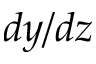<formula> <loc_0><loc_0><loc_500><loc_500>d y / d z</formula> 